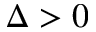<formula> <loc_0><loc_0><loc_500><loc_500>\Delta > 0</formula> 